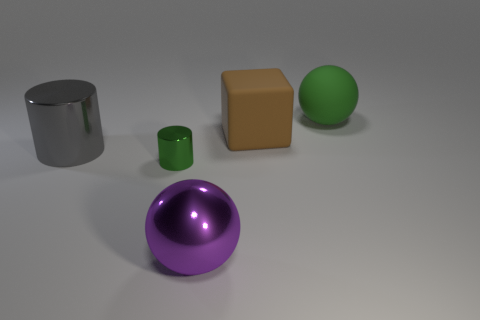The other rubber thing that is the same size as the green matte thing is what shape?
Offer a terse response. Cube. Are there any large cyan shiny things that have the same shape as the green matte object?
Provide a succinct answer. No. Are there fewer green cylinders than tiny green metal blocks?
Your answer should be very brief. No. There is a ball behind the green metallic cylinder; is its size the same as the matte thing that is on the left side of the big rubber ball?
Make the answer very short. Yes. How many things are brown things or gray things?
Offer a terse response. 2. How big is the ball in front of the small green object?
Provide a short and direct response. Large. How many metallic cylinders are to the right of the sphere that is behind the big shiny object that is on the left side of the small green cylinder?
Ensure brevity in your answer.  0. Do the rubber cube and the large cylinder have the same color?
Your answer should be very brief. No. What number of green objects are both behind the big block and on the left side of the big purple ball?
Your answer should be very brief. 0. There is a green thing that is behind the tiny thing; what is its shape?
Your answer should be very brief. Sphere. 